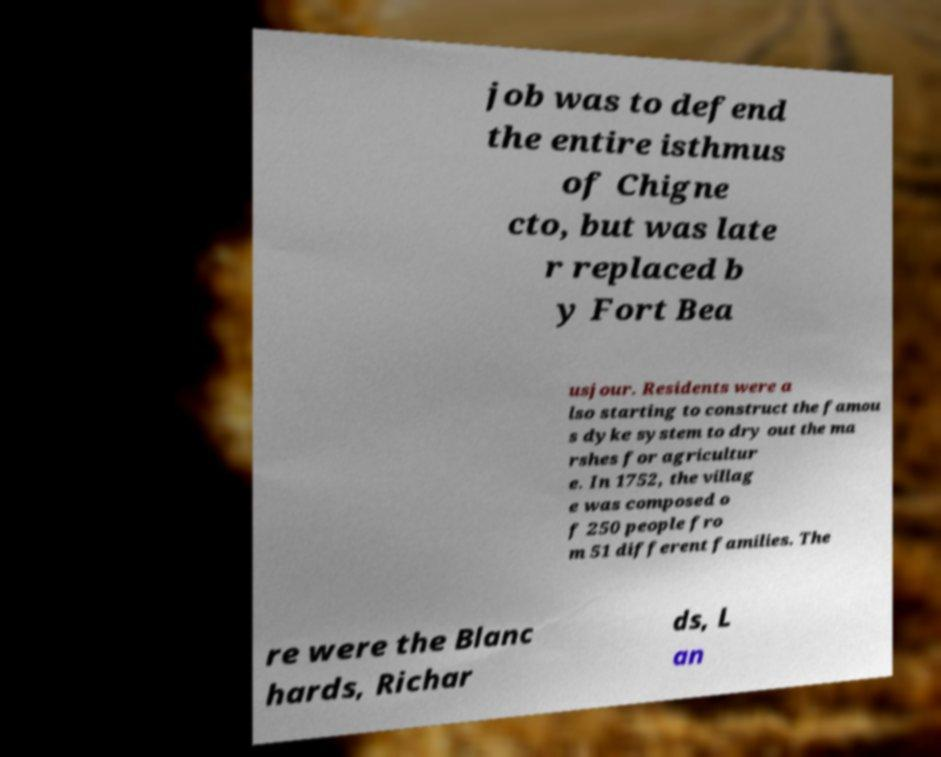There's text embedded in this image that I need extracted. Can you transcribe it verbatim? job was to defend the entire isthmus of Chigne cto, but was late r replaced b y Fort Bea usjour. Residents were a lso starting to construct the famou s dyke system to dry out the ma rshes for agricultur e. In 1752, the villag e was composed o f 250 people fro m 51 different families. The re were the Blanc hards, Richar ds, L an 